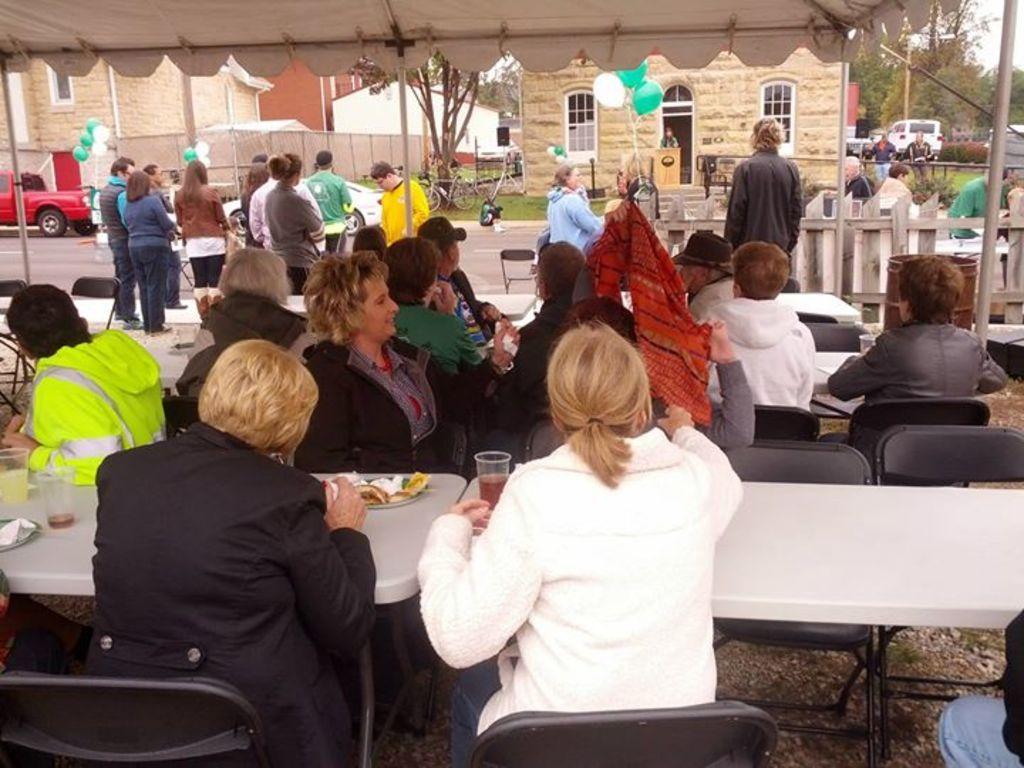Could you give a brief overview of what you see in this image? The image is taken on the street. There are chairs. There are many people. There is a table. There are glasses, plate, and the food placed on a table. In the background there are bicycles, a car, building and trees. At the top there is a tent. There are balloons. There is a fence. 